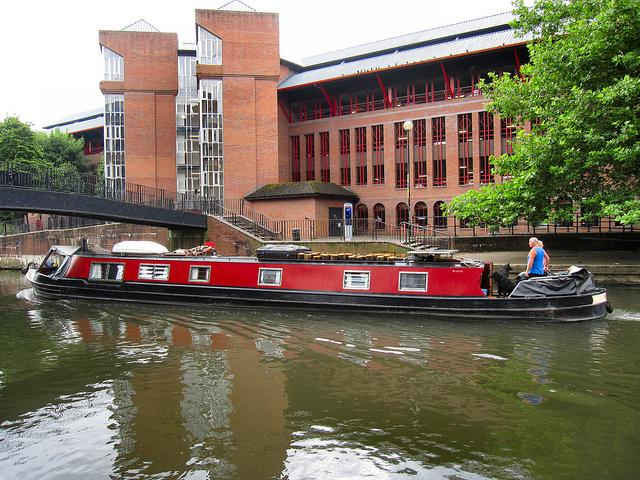How is this vessel being propelled? motor 